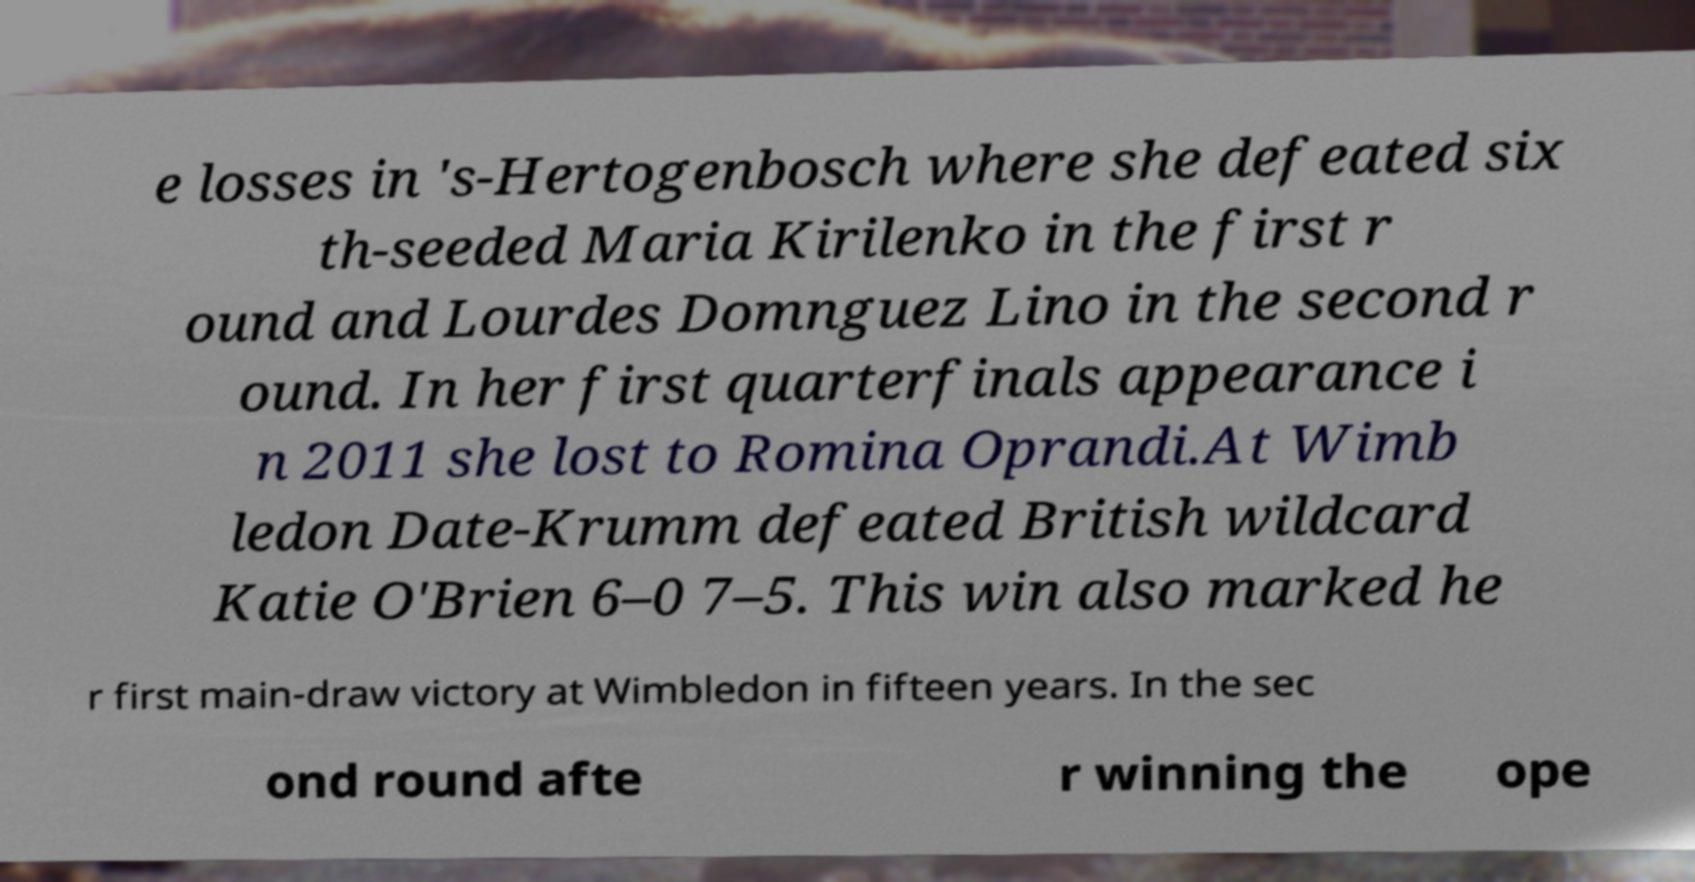Could you extract and type out the text from this image? e losses in 's-Hertogenbosch where she defeated six th-seeded Maria Kirilenko in the first r ound and Lourdes Domnguez Lino in the second r ound. In her first quarterfinals appearance i n 2011 she lost to Romina Oprandi.At Wimb ledon Date-Krumm defeated British wildcard Katie O'Brien 6–0 7–5. This win also marked he r first main-draw victory at Wimbledon in fifteen years. In the sec ond round afte r winning the ope 